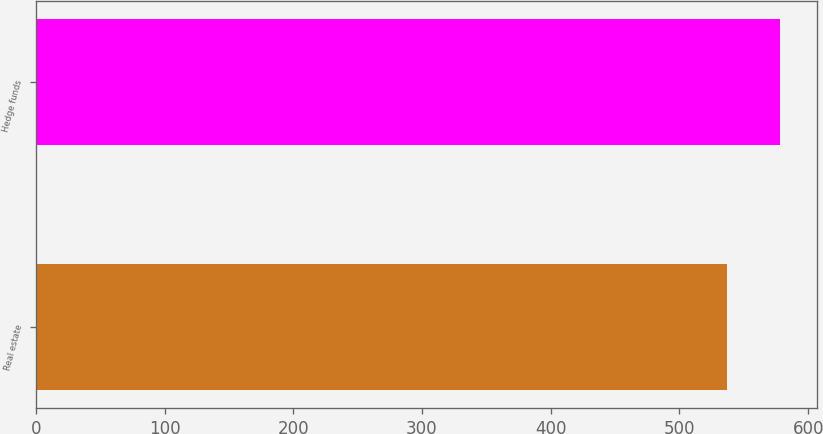<chart> <loc_0><loc_0><loc_500><loc_500><bar_chart><fcel>Real estate<fcel>Hedge funds<nl><fcel>537<fcel>578<nl></chart> 